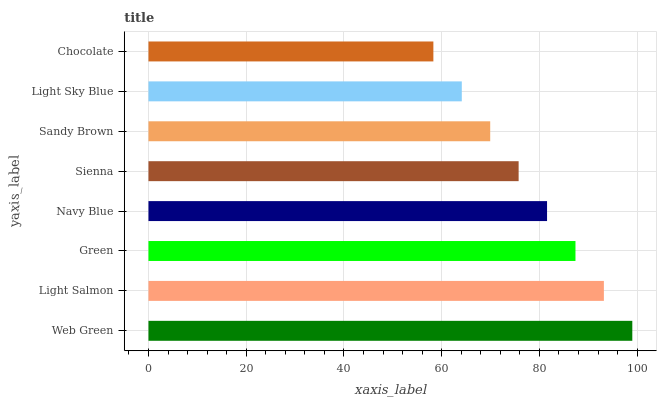Is Chocolate the minimum?
Answer yes or no. Yes. Is Web Green the maximum?
Answer yes or no. Yes. Is Light Salmon the minimum?
Answer yes or no. No. Is Light Salmon the maximum?
Answer yes or no. No. Is Web Green greater than Light Salmon?
Answer yes or no. Yes. Is Light Salmon less than Web Green?
Answer yes or no. Yes. Is Light Salmon greater than Web Green?
Answer yes or no. No. Is Web Green less than Light Salmon?
Answer yes or no. No. Is Navy Blue the high median?
Answer yes or no. Yes. Is Sienna the low median?
Answer yes or no. Yes. Is Web Green the high median?
Answer yes or no. No. Is Light Sky Blue the low median?
Answer yes or no. No. 